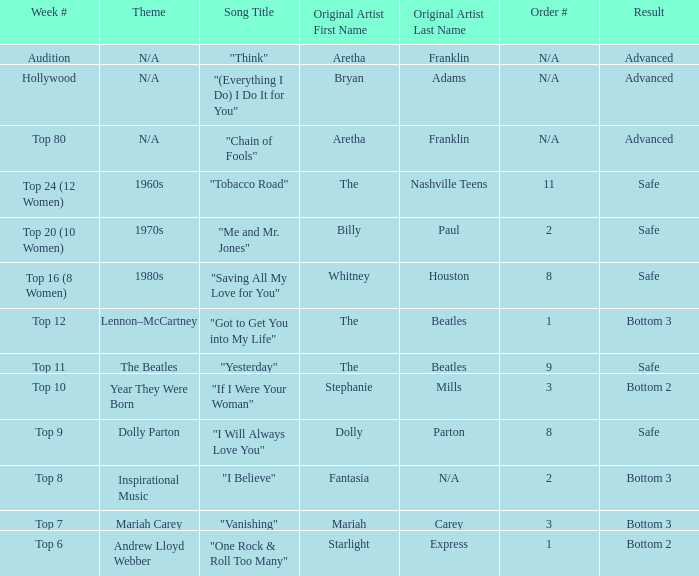Name the week number for andrew lloyd webber Top 6. 